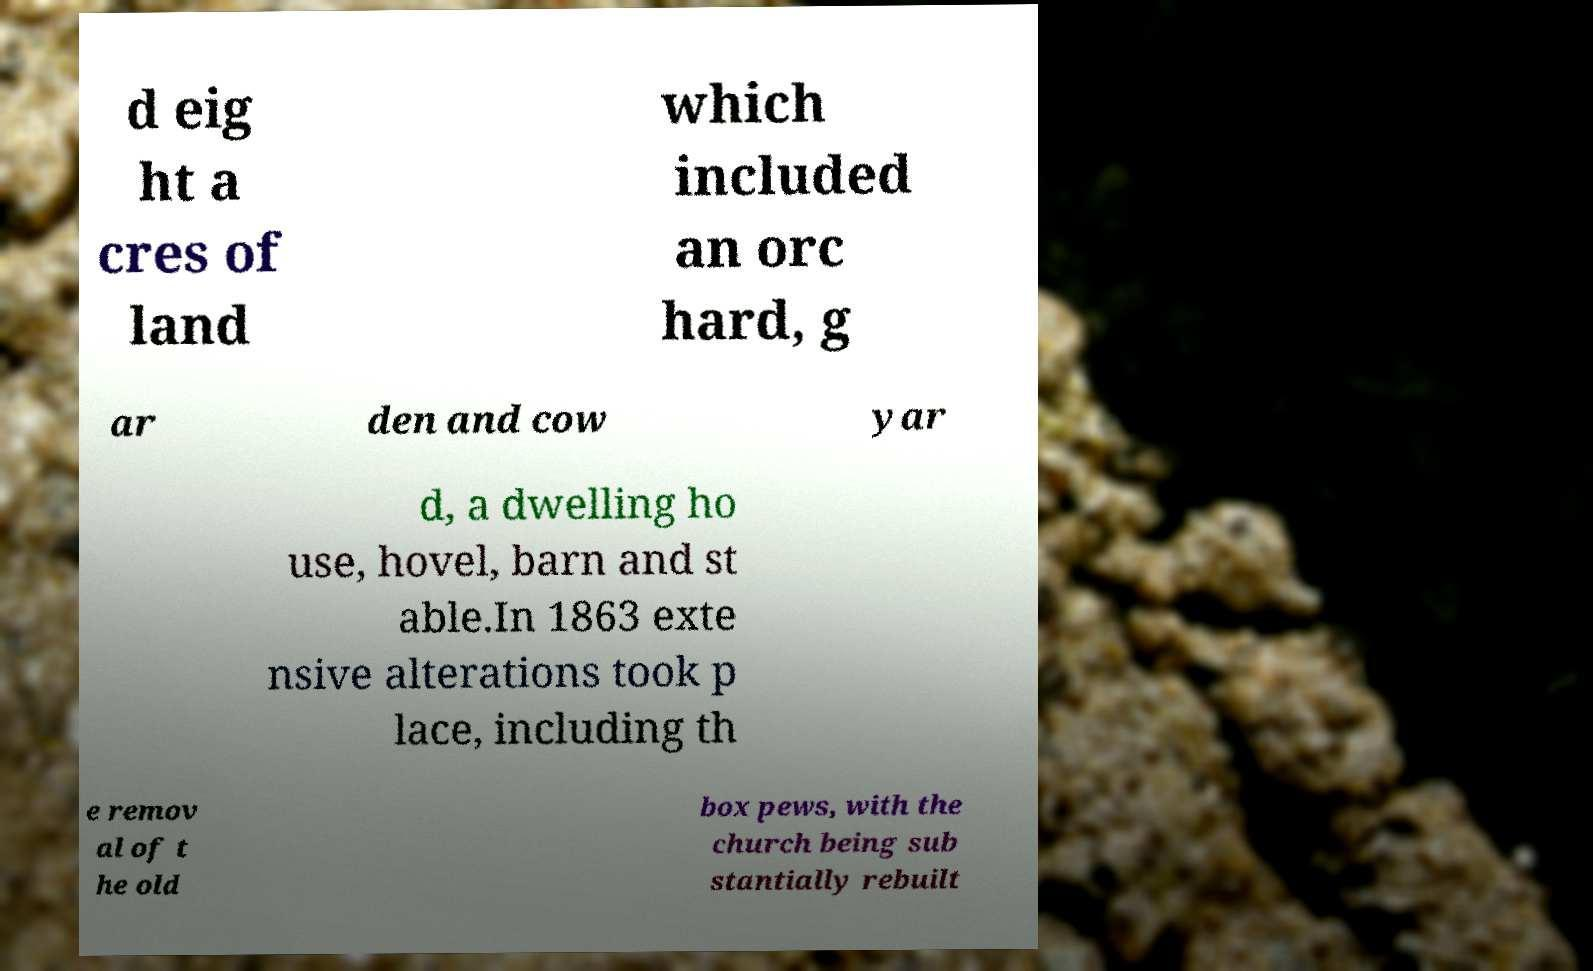For documentation purposes, I need the text within this image transcribed. Could you provide that? d eig ht a cres of land which included an orc hard, g ar den and cow yar d, a dwelling ho use, hovel, barn and st able.In 1863 exte nsive alterations took p lace, including th e remov al of t he old box pews, with the church being sub stantially rebuilt 